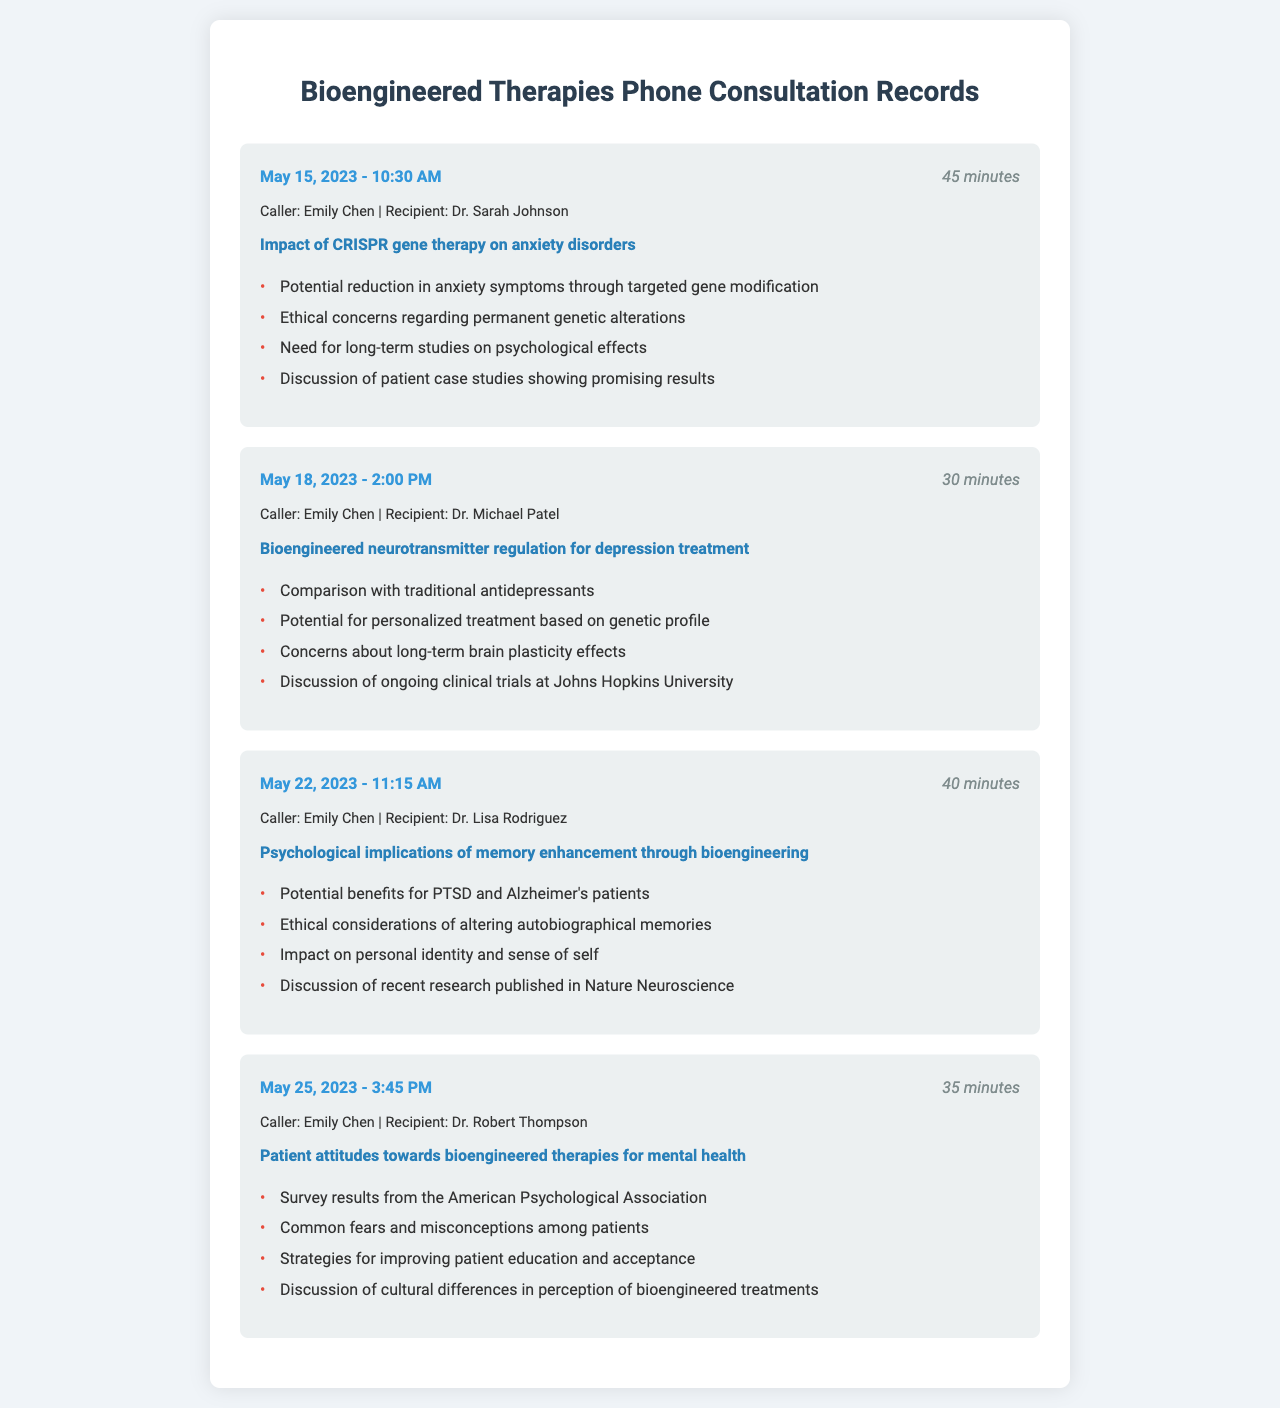What is the date of the consultation about CRISPR gene therapy? The date is mentioned as May 15, 2023.
Answer: May 15, 2023 Who was the recipient of the call regarding neurotransmitter regulation? The recipient of the call is Dr. Michael Patel.
Answer: Dr. Michael Patel How long did the consultation on memory enhancement last? The duration of the consultation is listed as 40 minutes.
Answer: 40 minutes What is a potential benefit discussed regarding memory enhancement? A potential benefit mentioned is for PTSD and Alzheimer's patients.
Answer: PTSD and Alzheimer's patients What are common fears among patients regarding bioengineered therapies? The document notes common fears and misconceptions among patients.
Answer: Fears and misconceptions Which institution is mentioned in connection with clinical trials? The clinical trials are connected to Johns Hopkins University.
Answer: Johns Hopkins University What ethical consideration is discussed in relation to memory enhancement? The ethical consideration is altering autobiographical memories.
Answer: Altering autobiographical memories How many participants were involved in the consultation about patient attitudes? The document does not specify the number of participants, focusing instead on survey results.
Answer: Not specified What is the focus of Dr. Robert Thompson's consultation? The focus is on patient attitudes towards bioengineered therapies for mental health.
Answer: Patient attitudes towards bioengineered therapies for mental health 